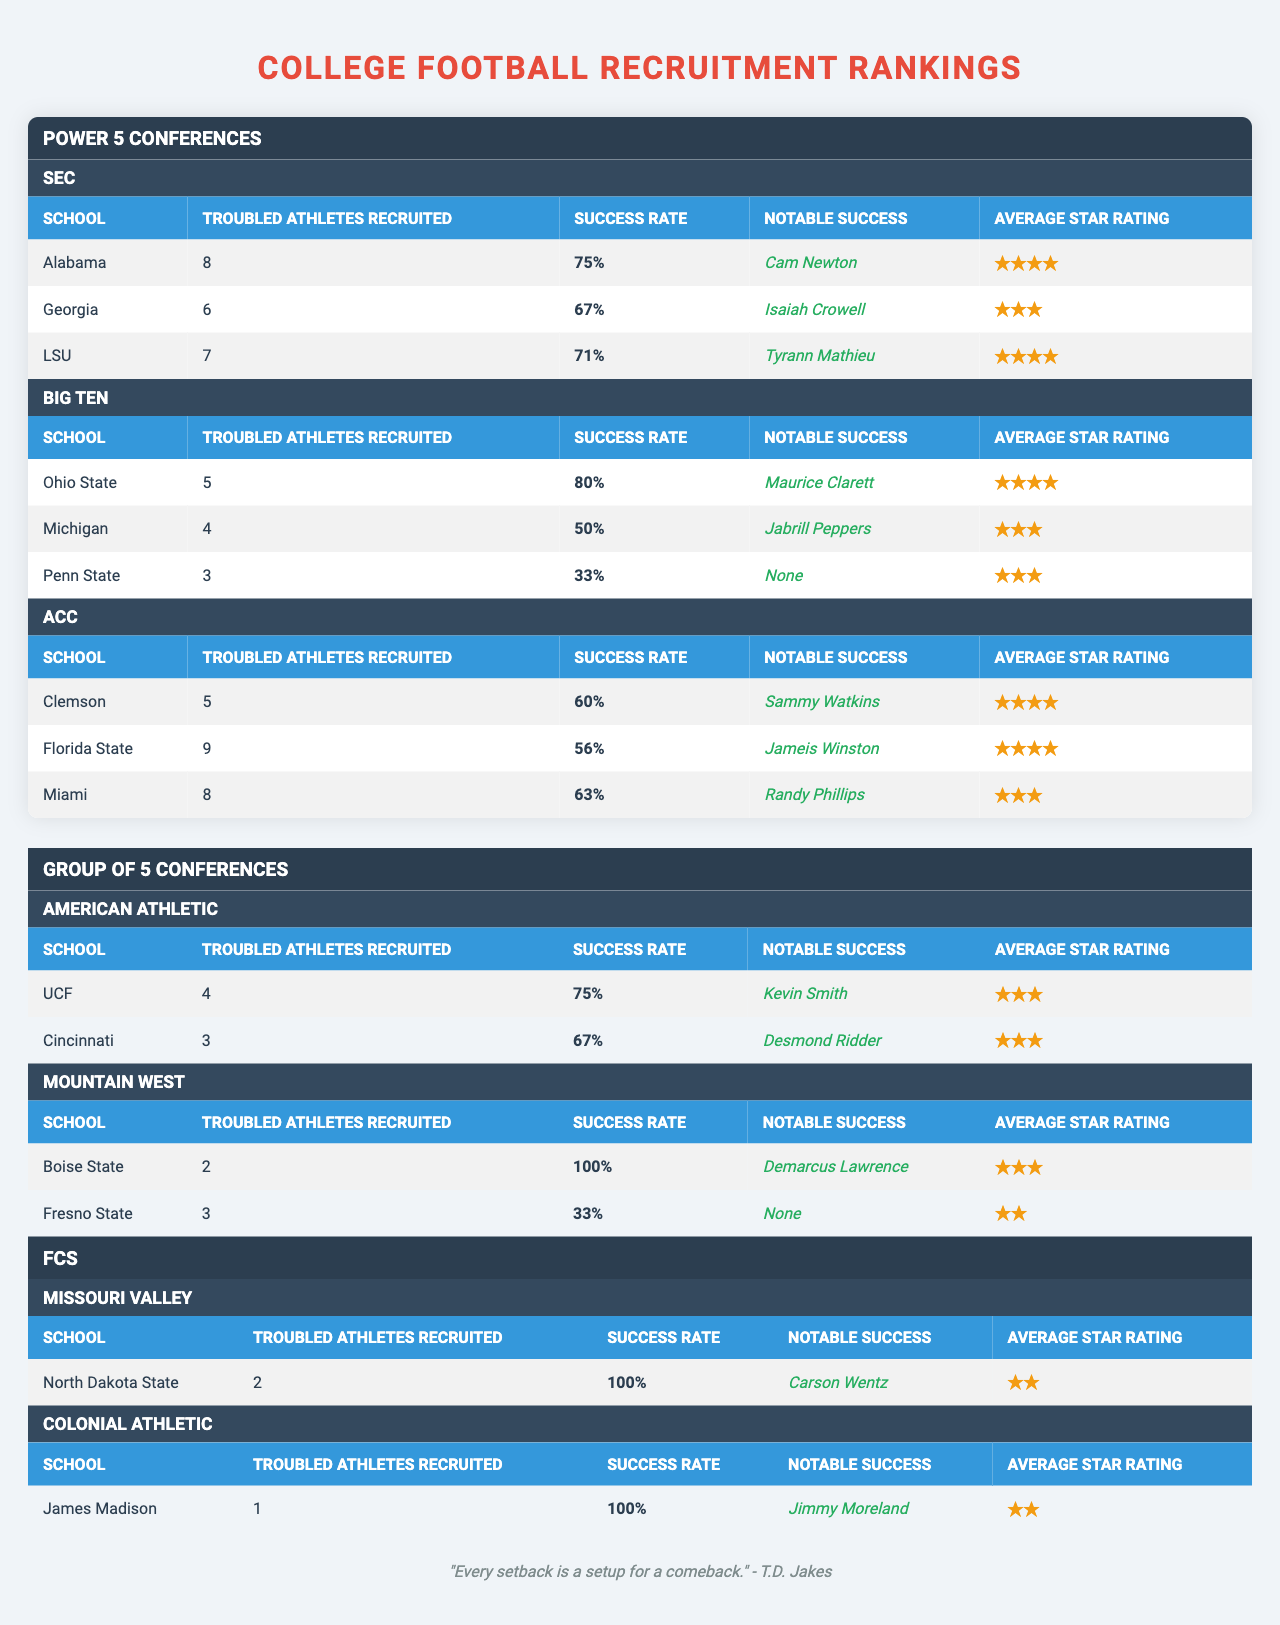What school has the highest success rate for troubled athletes? Looking at the table, Ohio State has a success rate of 80%, which is the highest among all listed schools.
Answer: Ohio State What is the average star rating of LSU? LSU has an average star rating of 4.0, as stated in the table.
Answer: 4.0 How many troubled athletes were recruited by Florida State? The table indicates that Florida State recruited 9 troubled athletes.
Answer: 9 Which school has the lowest success rate? Penn State shows the lowest success rate at 33%, according to the table.
Answer: Penn State How many troubled athletes were recruited by Group of 5 teams combined? Adding the troubled athletes recruited: 4 (UCF) + 3 (Cincinnati) + 2 (Boise State) + 3 (Fresno State) = 12.
Answer: 12 What percentage of troubled athletes recruited by Alabama achieved success? Alabama has a success rate of 75% for the troubled athletes it recruited, as per the table data.
Answer: 75% Is there any school in the FCS with a recruitment success rate of 100%? Yes, both North Dakota State and James Madison have a success rate of 100%, as outlined in the table.
Answer: Yes What is the total number of troubled athletes recruited by the SEC? The SEC totals: 8 (Alabama) + 6 (Georgia) + 7 (LSU) = 21.
Answer: 21 Does Georgia have a notable success story listed in the table? Yes, Georgia's notable success mentioned is Isaiah Crowell.
Answer: Yes Which Power 5 Conference has the least success overall for troubled athletes? Calculating success rates for each school's troubled athletes in the Power 5 shows that the Big Ten has the lowest average success rate: (80% + 50% + 33%)/3 = 54.3%.
Answer: Big Ten 